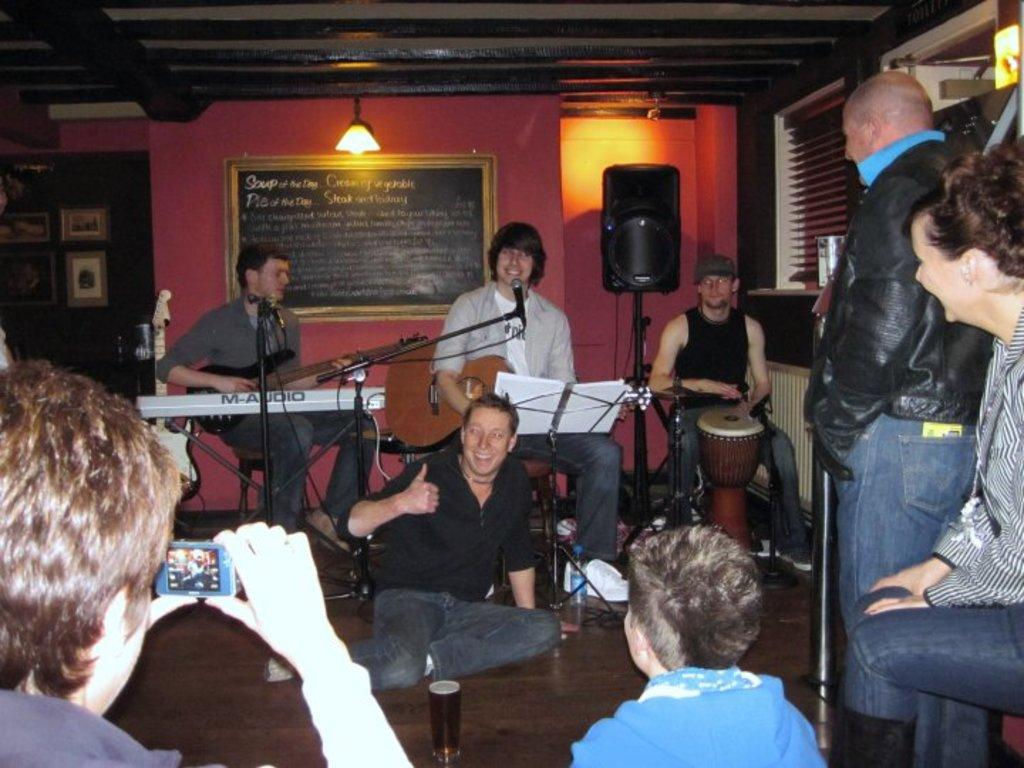What is happening in the image? There are three men performing in a live music, and there is a man posing to the camera. Can you describe the actions of the three men? The three men are performing in a live music, which suggests they are playing musical instruments or singing. What is the man posing to the camera doing? The man posing to the camera is likely having his picture taken or posing for a photograph. What type of detail can be seen on the quince in the image? There is no quince present in the image, so it is not possible to answer that question. 